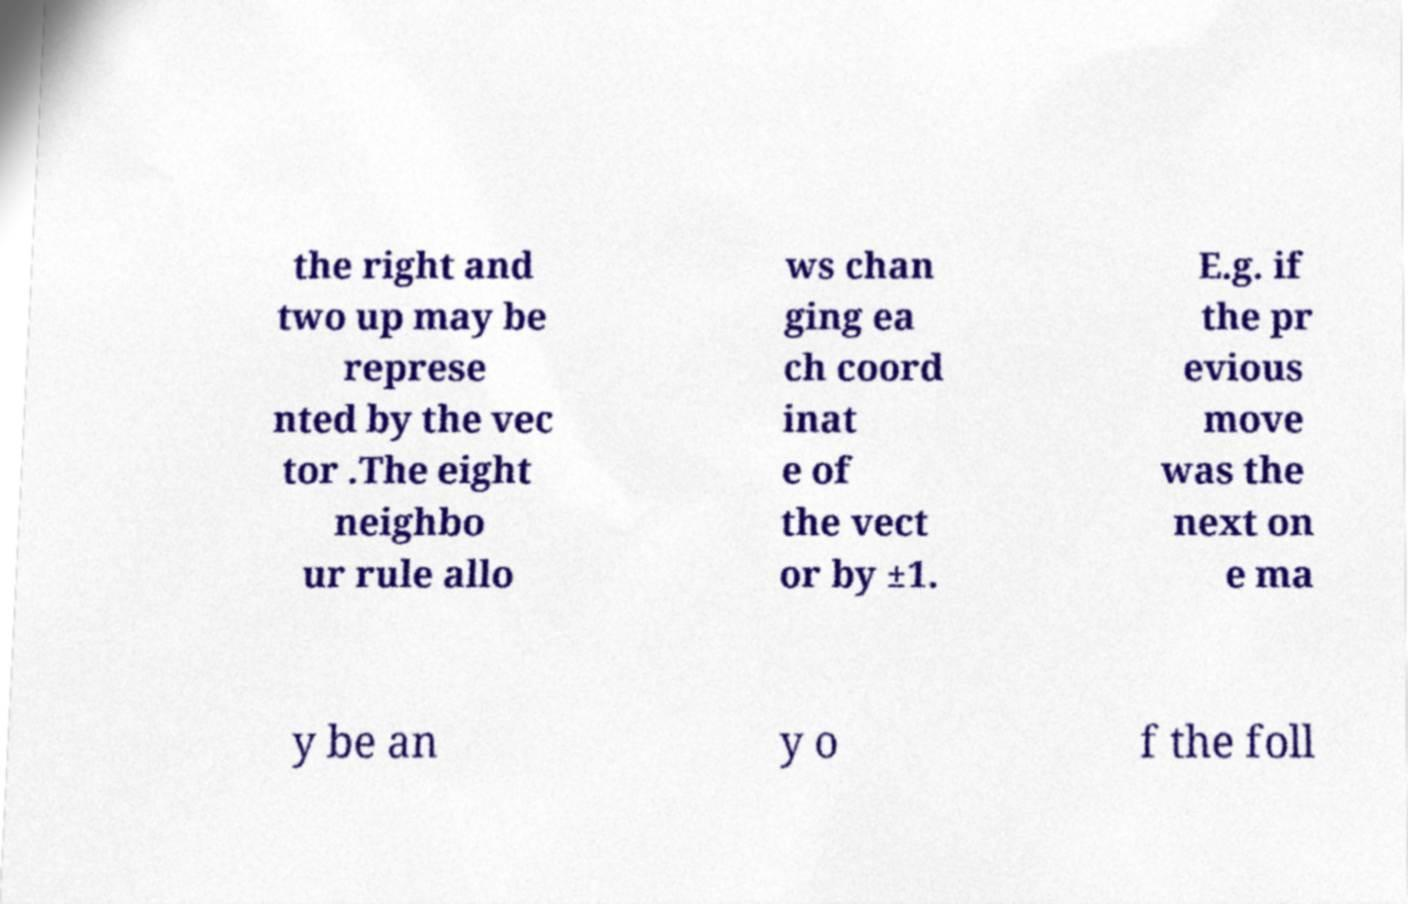What messages or text are displayed in this image? I need them in a readable, typed format. the right and two up may be represe nted by the vec tor .The eight neighbo ur rule allo ws chan ging ea ch coord inat e of the vect or by ±1. E.g. if the pr evious move was the next on e ma y be an y o f the foll 